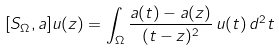<formula> <loc_0><loc_0><loc_500><loc_500>[ S _ { \Omega } , a ] u ( z ) = \int _ { \Omega } \frac { a ( t ) - a ( z ) } { ( t - z ) ^ { 2 } } \, u ( t ) \, d ^ { 2 } t</formula> 